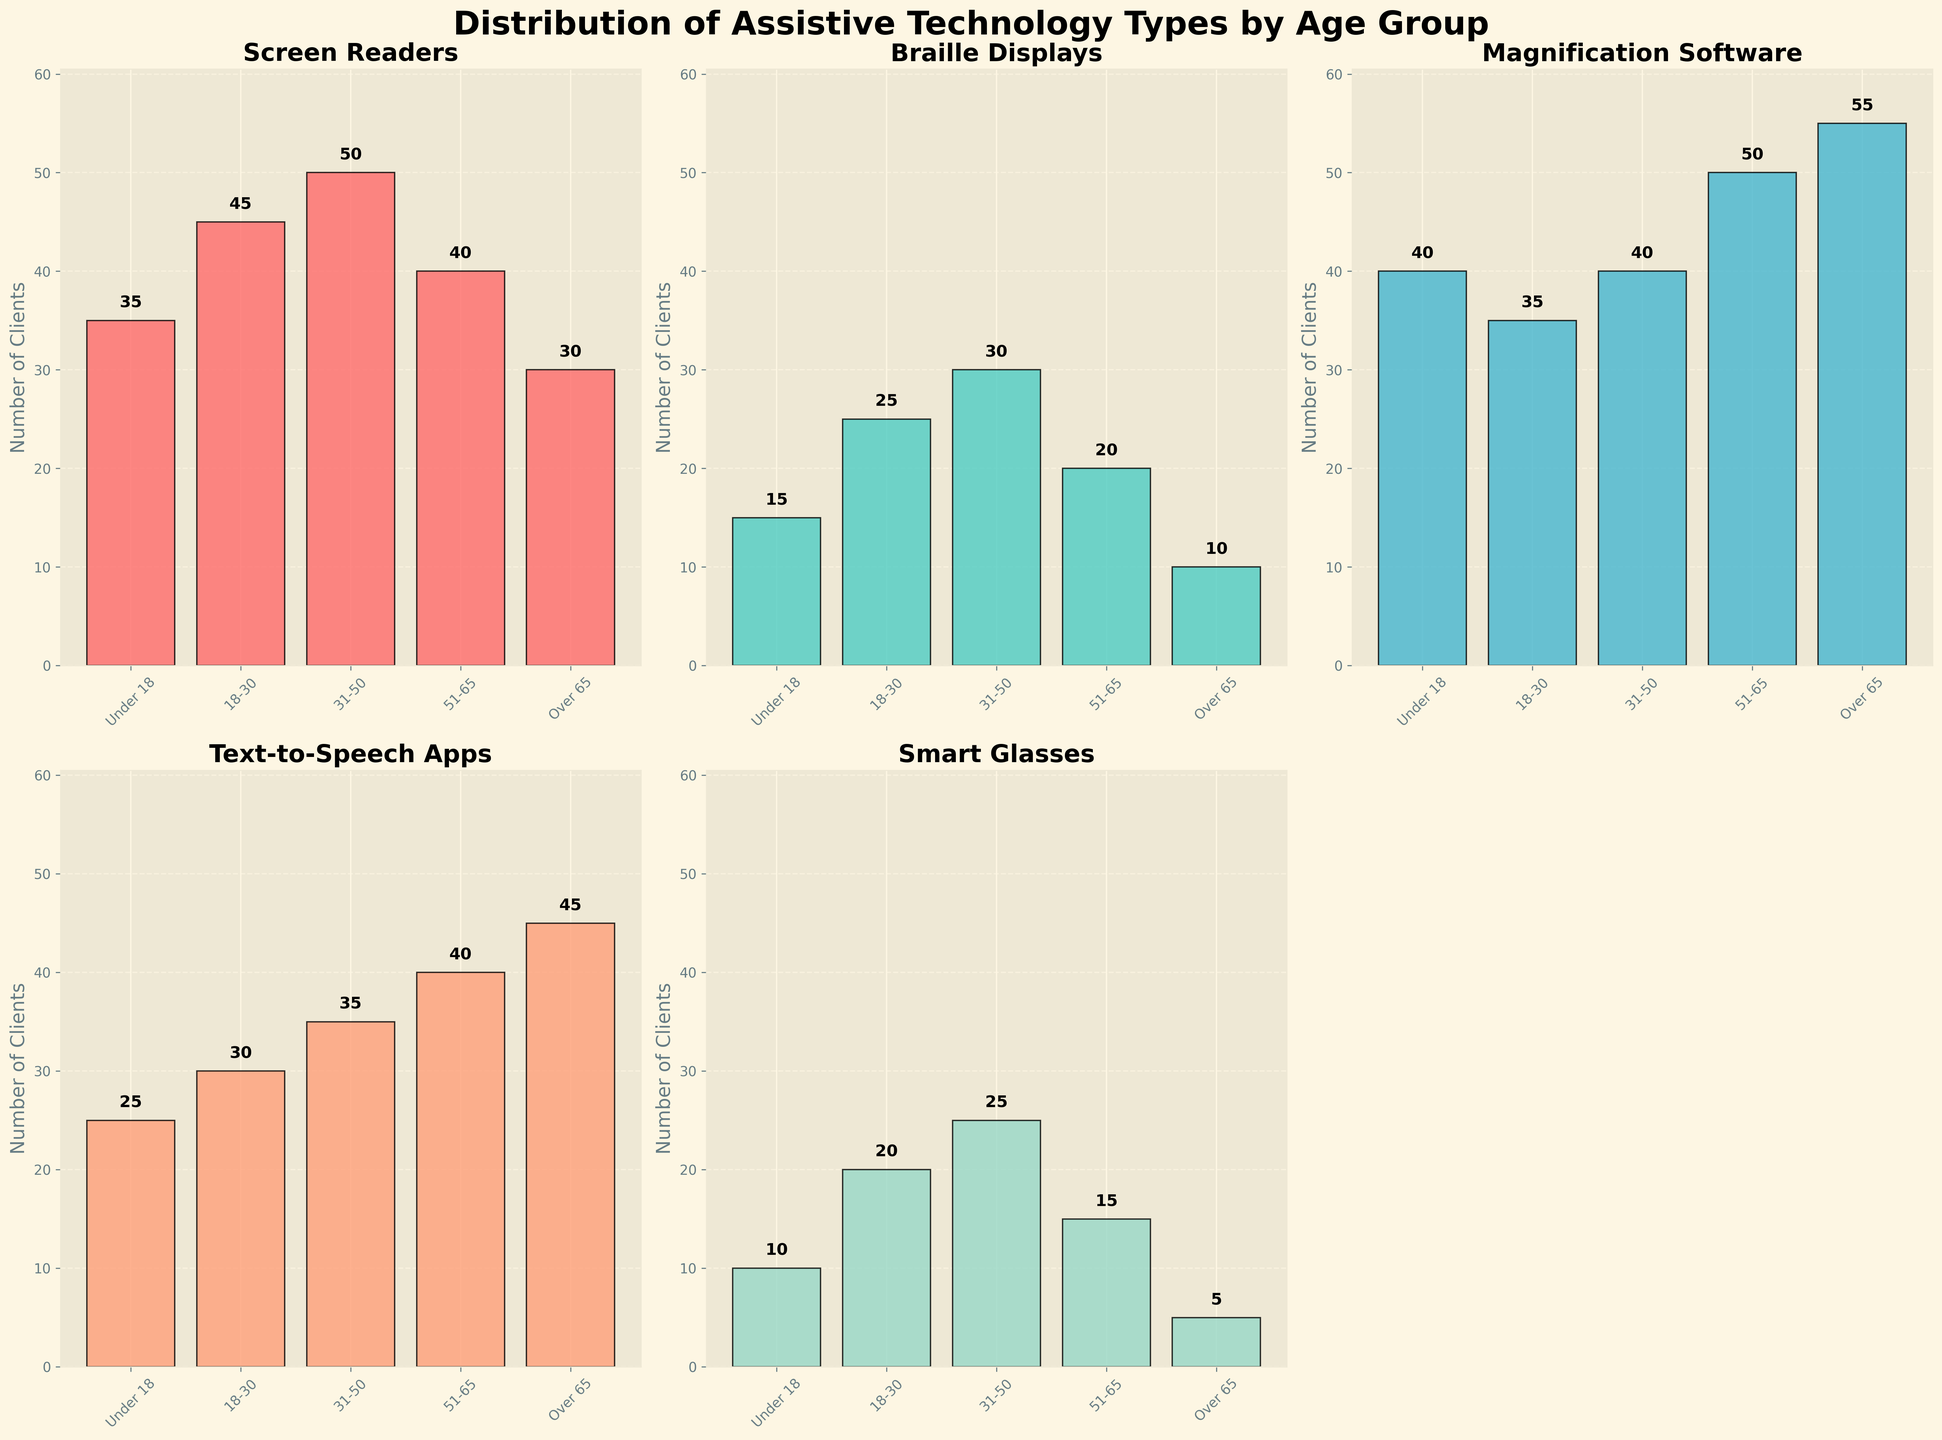What's the title of the figure? The title of the figure is prominently displayed at the top, which indicates the main subject of the visualization.
Answer: Distribution of Assistive Technology Types by Age Group What age group has the highest number of clients using Braille Displays? Looking at the bar heights for the Braille Displays subplot, the age group with the tallest bar represents the most clients.
Answer: 31-50 How many clients in total use Smart Glasses across all age groups? Sum up the values of Smart Glasses for each age group (10 + 20 + 25 + 15 + 5).
Answer: 75 Which age group uses magnification software the most, and how many clients are in this group? Examine the Magnification Software subplot and identify the tallest bar. The corresponding age group is the one with the highest usage.
Answer: Over 65, 55 Which assistive technology has the lowest usage in the 'Under 18' age group? Look at the bars for the 'Under 18' age group across all subplots and find the shortest bar.
Answer: Smart Glasses What is the difference in the number of clients using Text-to-Speech Apps between the '51-65' and 'Over 65' age groups? Identify the Text-to-Speech Apps bars for the '51-65' and 'Over 65' age groups, then subtract the smaller value from the larger value (45 - 40).
Answer: 5 Do more clients in the '18-30' age group use Screen Readers or Braille Displays? Compare the heights of the bars for '18-30' in the Screen Readers and Braille Displays subplots.
Answer: Screen Readers What is the total number of clients using assistive technologies in the '31-50' age group? Sum up all the values for the '31-50' age group across all subplots (50 + 30 + 40 + 35 + 25).
Answer: 180 Which technology shows the most variance in usage across all age groups? Compare the range (difference between the highest and lowest values) of each technology across age groups. Screen Readers: 50-30=20, Braille Displays: 30-10=20, Magnification Software: 55-35=20, Text-to-Speech Apps: 45-25=20, Smart Glasses: 25-5=20. All have the same.
Answer: Equal variance 